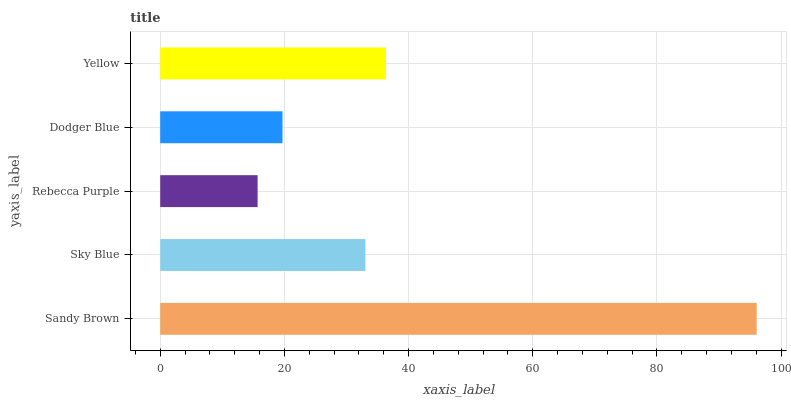Is Rebecca Purple the minimum?
Answer yes or no. Yes. Is Sandy Brown the maximum?
Answer yes or no. Yes. Is Sky Blue the minimum?
Answer yes or no. No. Is Sky Blue the maximum?
Answer yes or no. No. Is Sandy Brown greater than Sky Blue?
Answer yes or no. Yes. Is Sky Blue less than Sandy Brown?
Answer yes or no. Yes. Is Sky Blue greater than Sandy Brown?
Answer yes or no. No. Is Sandy Brown less than Sky Blue?
Answer yes or no. No. Is Sky Blue the high median?
Answer yes or no. Yes. Is Sky Blue the low median?
Answer yes or no. Yes. Is Dodger Blue the high median?
Answer yes or no. No. Is Dodger Blue the low median?
Answer yes or no. No. 